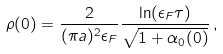<formula> <loc_0><loc_0><loc_500><loc_500>\rho ( 0 ) = \frac { 2 } { ( \pi a ) ^ { 2 } \epsilon _ { F } } \frac { \ln ( \epsilon _ { F } \tau ) } { \sqrt { 1 + \alpha _ { 0 } ( 0 ) } } \, ,</formula> 